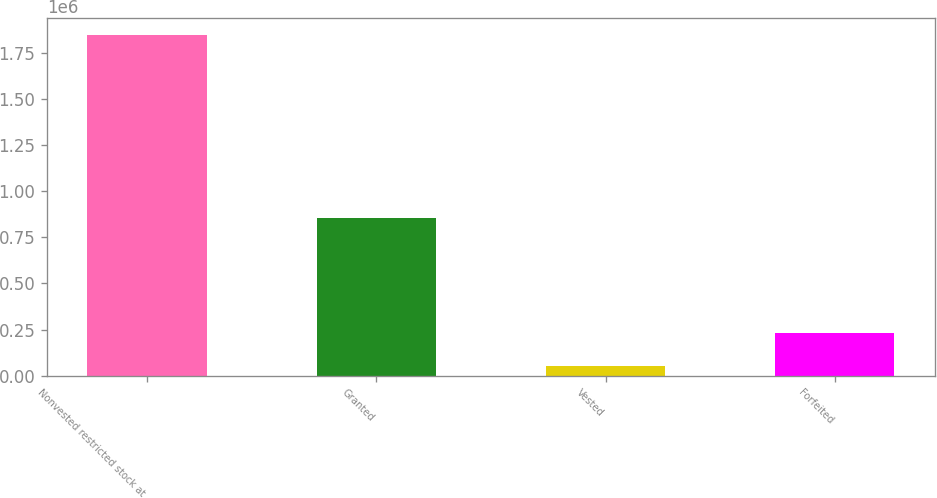Convert chart to OTSL. <chart><loc_0><loc_0><loc_500><loc_500><bar_chart><fcel>Nonvested restricted stock at<fcel>Granted<fcel>Vested<fcel>Forfeited<nl><fcel>1.84498e+06<fcel>852353<fcel>51206<fcel>230583<nl></chart> 